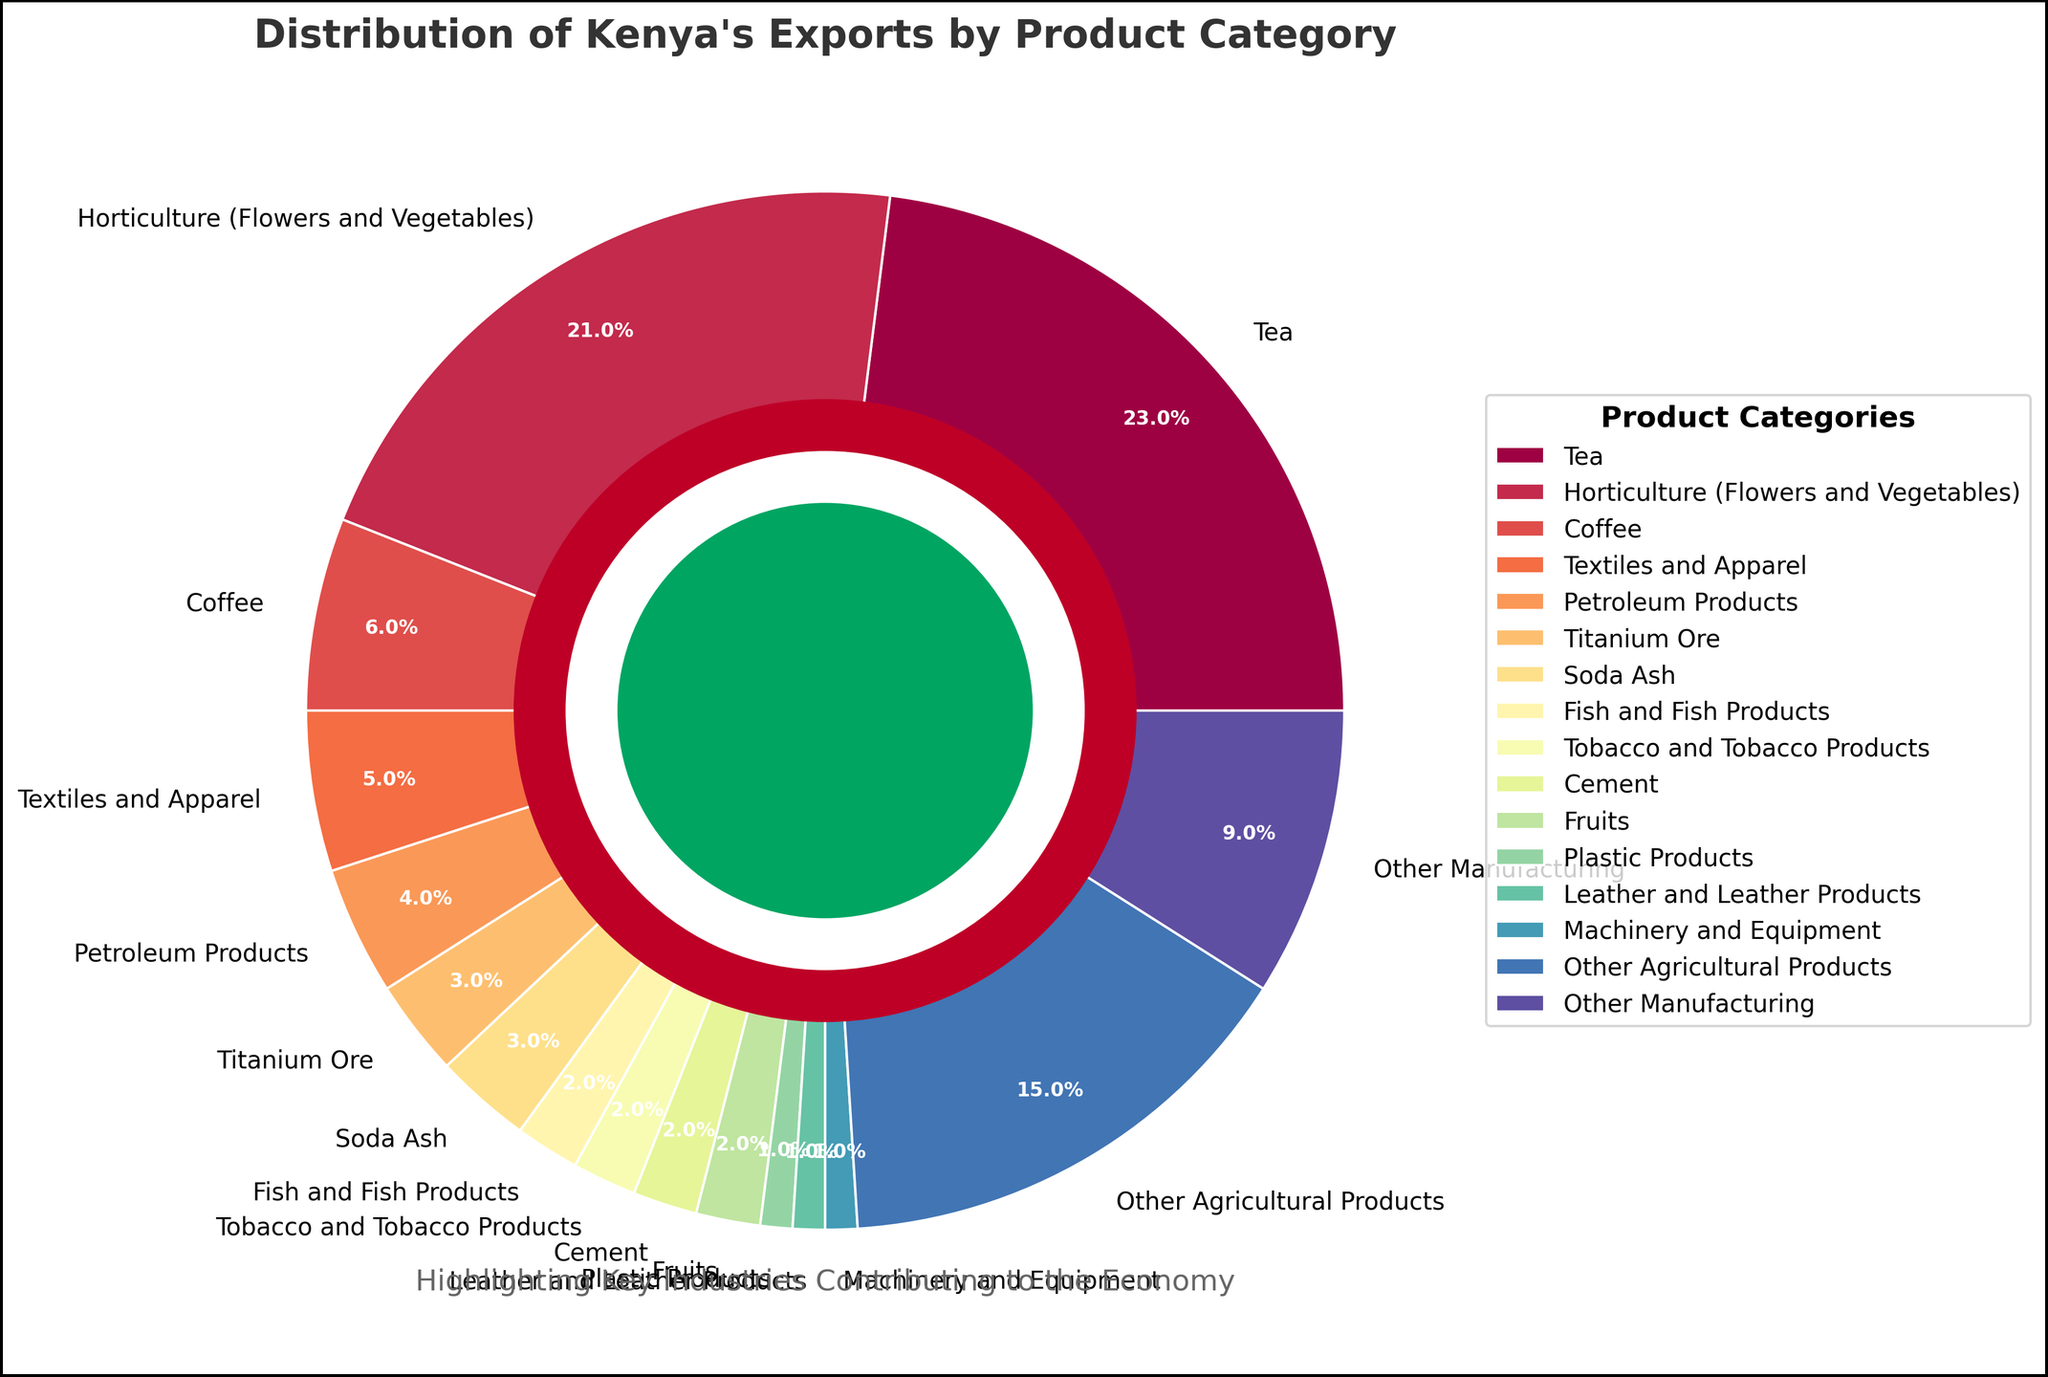Which product category has the highest percentage of exports? By looking at the figure, the segment labeled "Tea" is the largest, representing 23% of the total exports.
Answer: Tea How much more percentage do Tea exports have compared to Coffee exports? The percentage for Tea is 23% and for Coffee is 6%. Subtracting the percentage for Coffee from that of Tea gives: 23% - 6% = 17%.
Answer: 17% Which two product categories have the same export percentage? By observing the segments, "Soda Ash," "Fish and Fish Products," "Tobacco and Tobacco Products," "Cement," and "Fruits" all have a segment representing 2% in the chart.
Answer: Fish and Fish Products & Tobacco and Tobacco Products What is the combined percentage of exports for the categories: Textiles and Apparel, Petroleum Products, and Titanium Ore? Adding the percentages for Textiles and Apparel (5%), Petroleum Products (4%), and Titanium Ore (3%) gives: 5% + 4% + 3% = 12%.
Answer: 12% Compare the percentage of Horticulture exports to the percentage of Other Agricultural Products exports. Which is greater and by how much? The percentage of Horticulture (Flowers and Vegetables) is 21%, while Other Agricultural Products is 15%. Subtracting the latter from the former gives: 21% - 15% = 6%. Horticulture exports are greater by 6%.
Answer: Horticulture by 6% What is the total percentage contribution of agricultural products to Kenya's exports? Sum the percentages of Tea (23%), Horticulture (Flowers and Vegetables) (21%), Coffee (6%), Tobacco and Tobacco Products (2%), Fruits (2%), Fish and Fish Products (2%), and Other Agricultural Products (15%). This gives us: 23% + 21% + 6% +2% + 2% + 2% + 15% = 71%.
Answer: 71% Which segment of the pie chart is represented in green color? Observing the colors, the segment representing "Other Agricultural Products" is shaded in green.
Answer: Other Agricultural Products What's the difference in export percentage between the largest and smallest product categories? The largest category is Tea at 23%, and the smallest categories (Machinery and Equipment and Plastic Products) are each at 1%. The difference is 23% - 1% = 22%.
Answer: 22% How many product categories have an export percentage of 1% or less? The chart segments representing Plastic Products, Leather and Leather Products, Machinery and Equipment are each less than or equal to 1%.
Answer: 3 What is the percentage of non-agricultural product exports when combined? Adding percentages for Petroleum Products (4%), Titanium Ore (3%), Soda Ash (3%), Cement (2%), Plastic Products (1%), Leather and Leather Products (1%), Machinery and Equipment (1%), Other Manufacturing (9%) gives: 4% + 3% + 3% + 2% + 1% + 1% + 1% + 9% = 24%.
Answer: 24% 